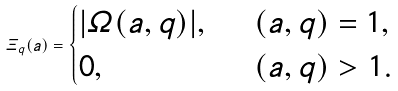<formula> <loc_0><loc_0><loc_500><loc_500>\varXi _ { q } ( a ) = \begin{cases} | \varOmega ( a , q ) | , \ \ & ( a , q ) = 1 , \\ 0 , & ( a , q ) > 1 . \end{cases}</formula> 